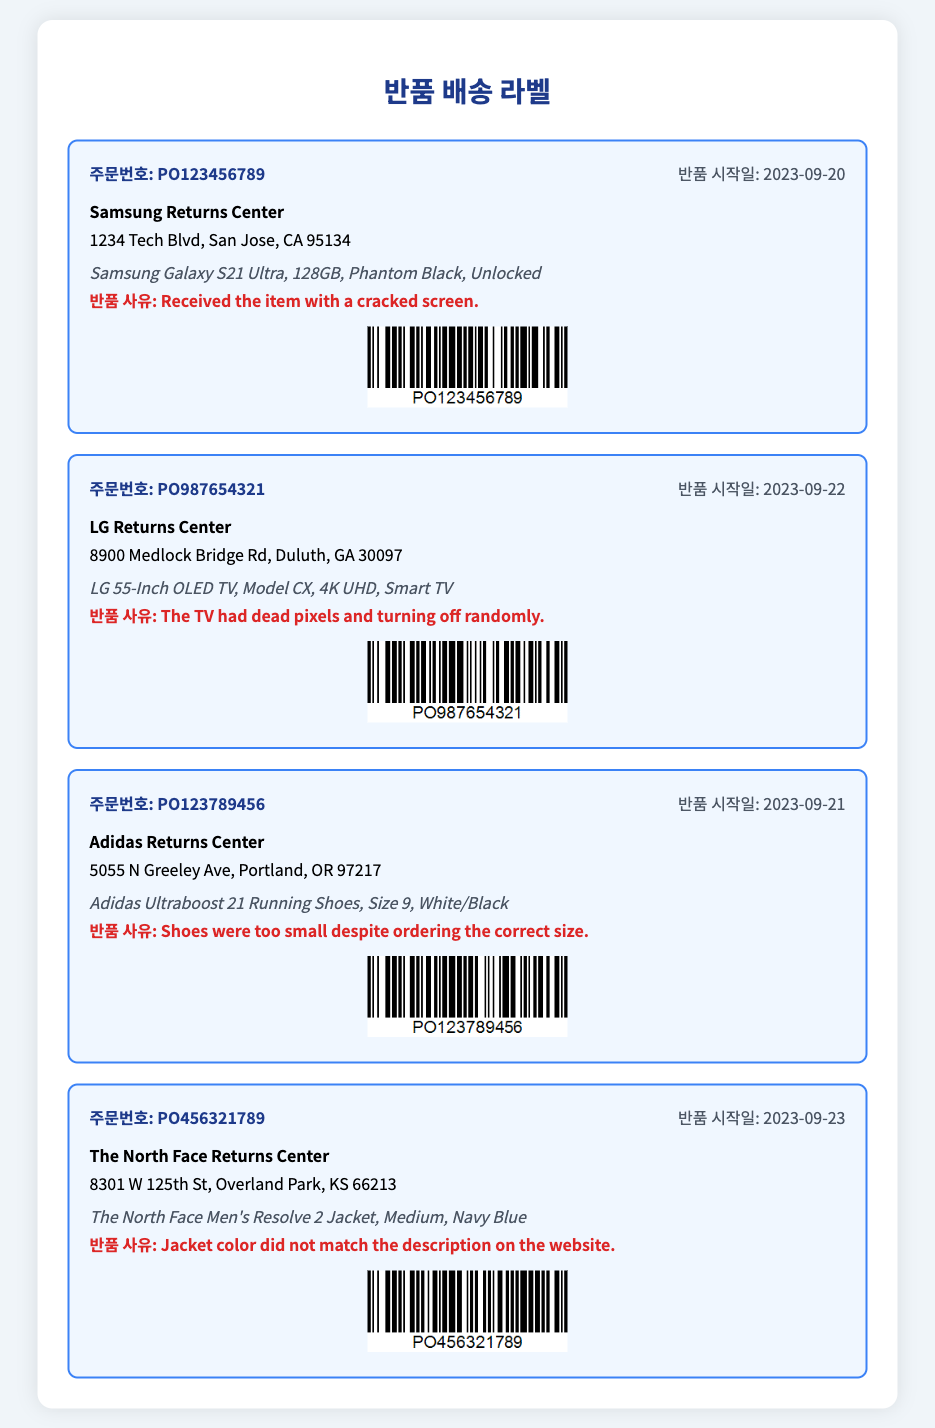what is the first order number? The first order number listed in the document is identified in the first shipping label.
Answer: PO123456789 who is the recipient for the second shipping label? The recipient for the second shipping label is indicated directly below the order number.
Answer: LG Returns Center what is the reason for the return of the Adidas shoes? The reason for the return can be found in the description provided in the Adidas shipping label.
Answer: Shoes were too small despite ordering the correct size what is the return date for the LG TV? The return date is specified in the label section of the LG shipping label.
Answer: 2023-09-22 what is the address for the Adidas Returns Center? The address can be located in the shipping label description directly underneath the recipient's name.
Answer: 5055 N Greeley Ave, Portland, OR 97217 how many items are listed for return? The total count of shipping labels indicates how many items are detailed in the document.
Answer: 4 what is the model of the TV being returned? The model of the TV is specified in the item description section of the LG shipping label.
Answer: Model CX what color is the Samsung Galaxy S21 Ultra? The color is mentioned in the item description of the Samsung shipping label.
Answer: Phantom Black what is the date for starting the return of the North Face jacket? The return starting date is explicitly mentioned in the North Face shipping label section.
Answer: 2023-09-23 